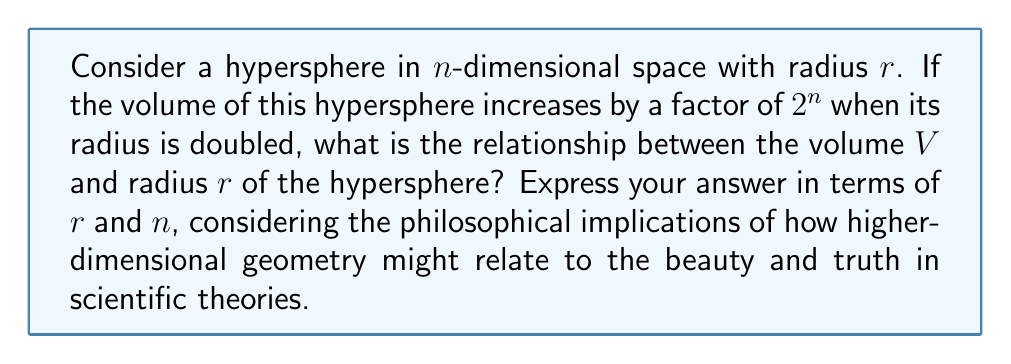Help me with this question. Let's approach this step-by-step:

1) In n-dimensional space, the volume of a hypersphere is given by the general formula:

   $$V = \frac{\pi^{n/2}}{\Gamma(n/2 + 1)} r^n$$

   where $\Gamma$ is the gamma function.

2) We're told that when the radius doubles, the volume increases by a factor of $2^n$. Let's express this mathematically:

   $$V(2r) = 2^n V(r)$$

3) Using the volume formula, we can write:

   $$\frac{\pi^{n/2}}{\Gamma(n/2 + 1)} (2r)^n = 2^n \cdot \frac{\pi^{n/2}}{\Gamma(n/2 + 1)} r^n$$

4) Simplify the left side:

   $$\frac{\pi^{n/2}}{\Gamma(n/2 + 1)} 2^n r^n = 2^n \cdot \frac{\pi^{n/2}}{\Gamma(n/2 + 1)} r^n$$

5) We can see that this equation is indeed true for all r and n, confirming the given information.

6) From this, we can deduce that the volume V is proportional to $r^n$:

   $$V \propto r^n$$

7) To turn this into an equation, we need a constant of proportionality. Let's call it k:

   $$V = k r^n$$

8) The value of k would be $\frac{\pi^{n/2}}{\Gamma(n/2 + 1)}$, but we don't need to specify this for the question at hand.

From a philosophical perspective, this relationship reveals a beautiful truth about higher-dimensional geometry: the way volume scales with radius in any dimension follows a simple power law. This elegance in higher dimensions might be seen as a reflection of the underlying beauty and simplicity of mathematical truths, even as they describe increasingly complex and abstract spaces.
Answer: $V = k r^n$, where k is a constant depending on n 